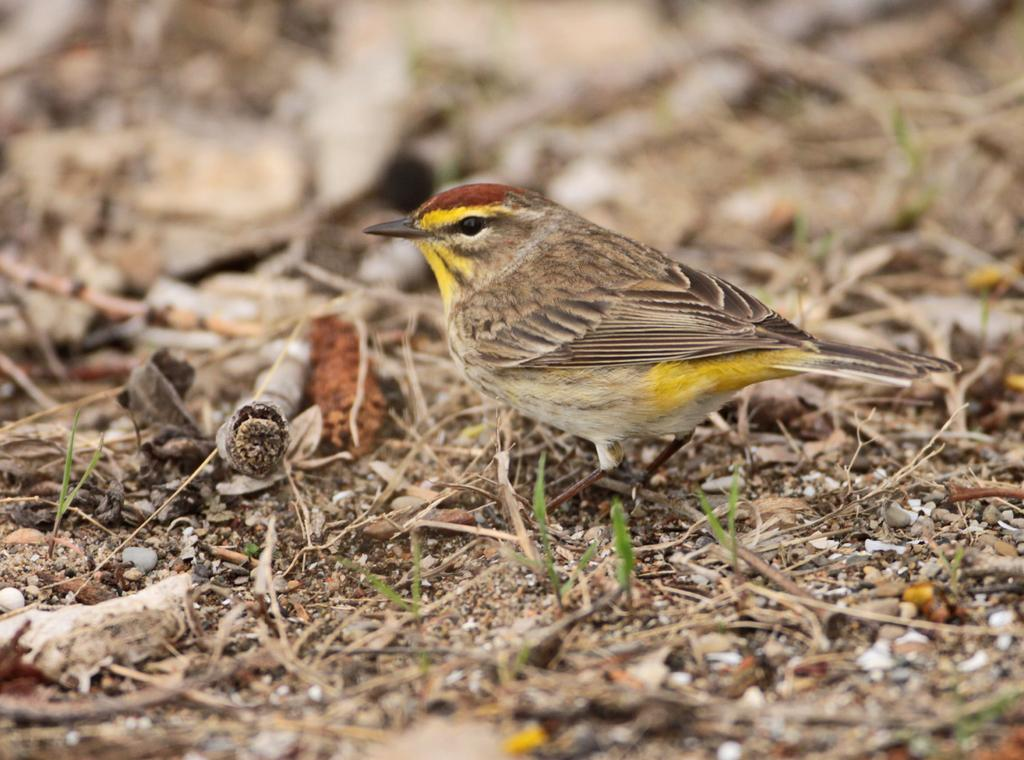What type of animal can be seen in the image? There is a bird in the image. Where is the bird located? The bird is on land. Can you describe the background of the image? The background of the image is blurred. What type of bottle is the bird holding in the image? There is no bottle present in the image; the bird is simply on land. 